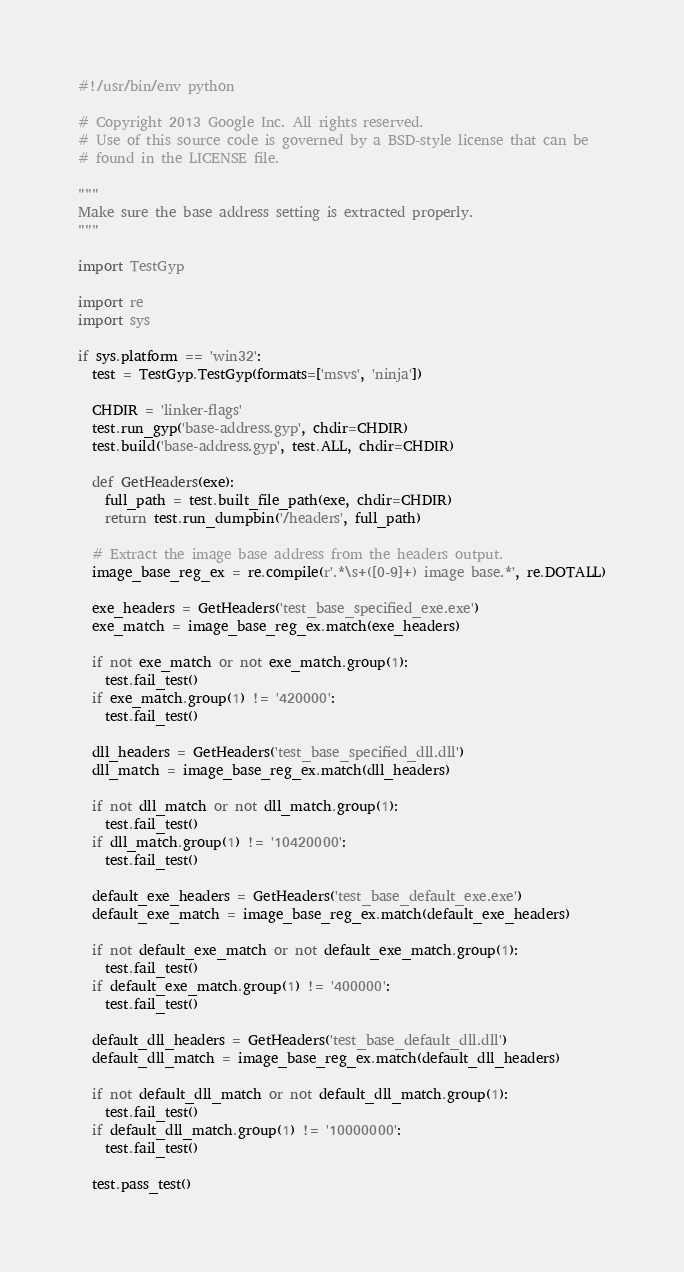Convert code to text. <code><loc_0><loc_0><loc_500><loc_500><_Python_>#!/usr/bin/env python

# Copyright 2013 Google Inc. All rights reserved.
# Use of this source code is governed by a BSD-style license that can be
# found in the LICENSE file.

"""
Make sure the base address setting is extracted properly.
"""

import TestGyp

import re
import sys

if sys.platform == 'win32':
  test = TestGyp.TestGyp(formats=['msvs', 'ninja'])

  CHDIR = 'linker-flags'
  test.run_gyp('base-address.gyp', chdir=CHDIR)
  test.build('base-address.gyp', test.ALL, chdir=CHDIR)

  def GetHeaders(exe):
    full_path = test.built_file_path(exe, chdir=CHDIR)
    return test.run_dumpbin('/headers', full_path)

  # Extract the image base address from the headers output.
  image_base_reg_ex = re.compile(r'.*\s+([0-9]+) image base.*', re.DOTALL)

  exe_headers = GetHeaders('test_base_specified_exe.exe')
  exe_match = image_base_reg_ex.match(exe_headers)

  if not exe_match or not exe_match.group(1):
    test.fail_test()
  if exe_match.group(1) != '420000':
    test.fail_test()

  dll_headers = GetHeaders('test_base_specified_dll.dll')
  dll_match = image_base_reg_ex.match(dll_headers)

  if not dll_match or not dll_match.group(1):
    test.fail_test()
  if dll_match.group(1) != '10420000':
    test.fail_test()

  default_exe_headers = GetHeaders('test_base_default_exe.exe')
  default_exe_match = image_base_reg_ex.match(default_exe_headers)

  if not default_exe_match or not default_exe_match.group(1):
    test.fail_test()
  if default_exe_match.group(1) != '400000':
    test.fail_test()

  default_dll_headers = GetHeaders('test_base_default_dll.dll')
  default_dll_match = image_base_reg_ex.match(default_dll_headers)

  if not default_dll_match or not default_dll_match.group(1):
    test.fail_test()
  if default_dll_match.group(1) != '10000000':
    test.fail_test()

  test.pass_test()
</code> 